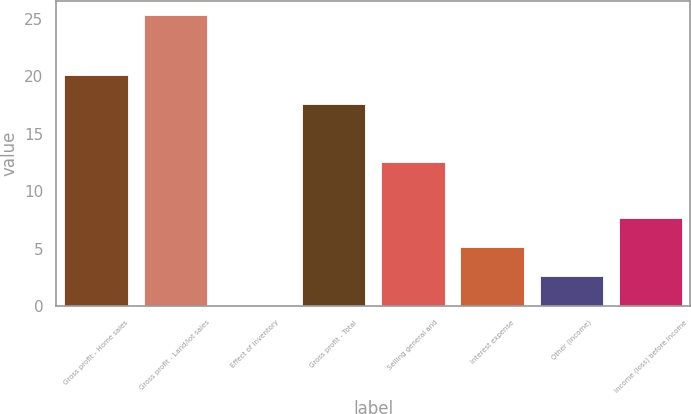Convert chart. <chart><loc_0><loc_0><loc_500><loc_500><bar_chart><fcel>Gross profit - Home sales<fcel>Gross profit - Land/lot sales<fcel>Effect of inventory<fcel>Gross profit - Total<fcel>Selling general and<fcel>Interest expense<fcel>Other (income)<fcel>Income (loss) before income<nl><fcel>20.12<fcel>25.3<fcel>0.1<fcel>17.6<fcel>12.5<fcel>5.14<fcel>2.62<fcel>7.66<nl></chart> 